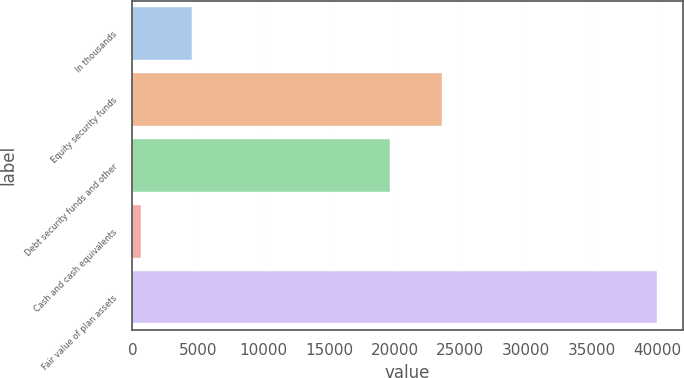<chart> <loc_0><loc_0><loc_500><loc_500><bar_chart><fcel>In thousands<fcel>Equity security funds<fcel>Debt security funds and other<fcel>Cash and cash equivalents<fcel>Fair value of plan assets<nl><fcel>4563.9<fcel>23581.9<fcel>19650<fcel>632<fcel>39951<nl></chart> 